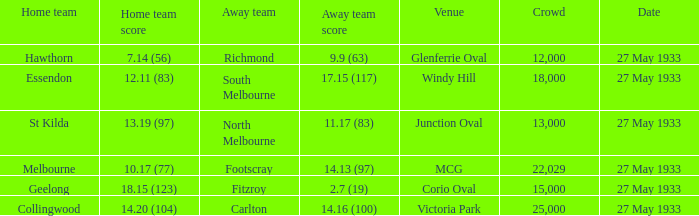How many individuals were present in the audience when the away team scored 2.7 (19) in the game? 15000.0. 